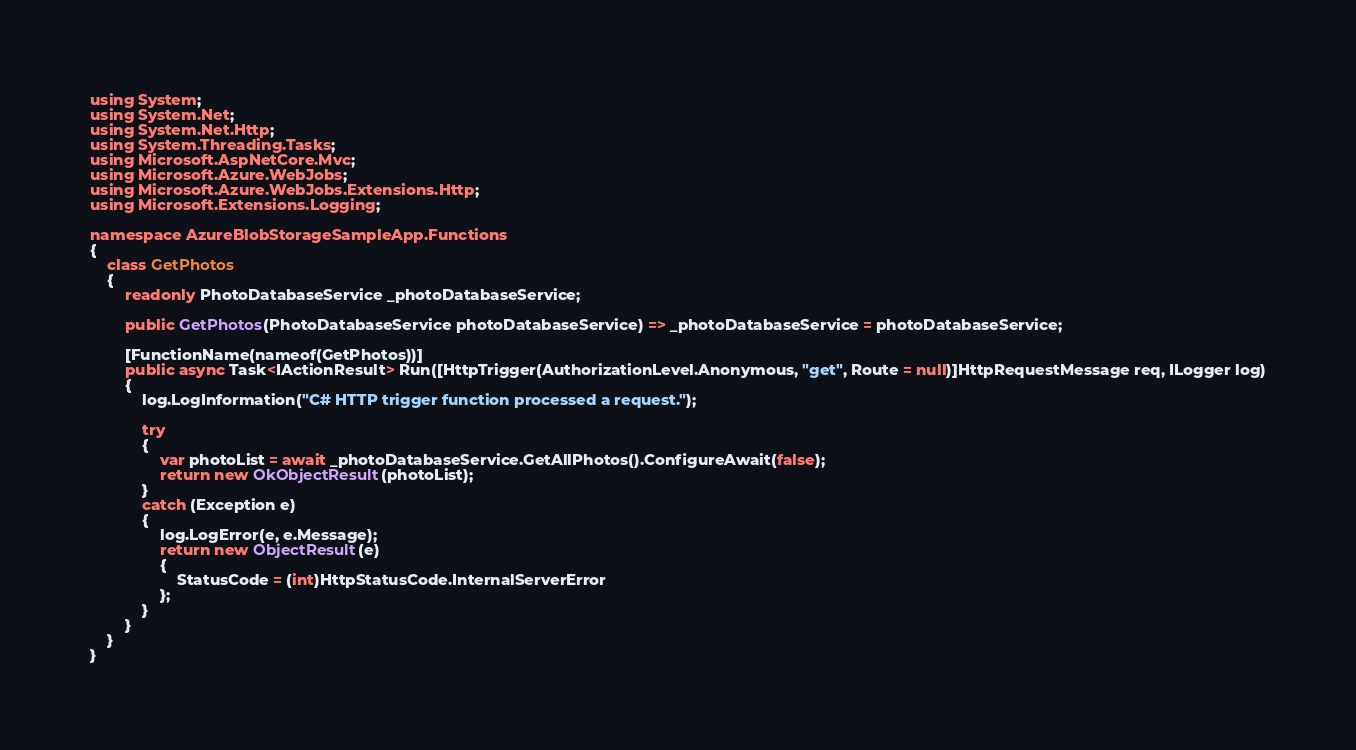<code> <loc_0><loc_0><loc_500><loc_500><_C#_>using System;
using System.Net;
using System.Net.Http;
using System.Threading.Tasks;
using Microsoft.AspNetCore.Mvc;
using Microsoft.Azure.WebJobs;
using Microsoft.Azure.WebJobs.Extensions.Http;
using Microsoft.Extensions.Logging;

namespace AzureBlobStorageSampleApp.Functions
{
    class GetPhotos
    {
        readonly PhotoDatabaseService _photoDatabaseService;

        public GetPhotos(PhotoDatabaseService photoDatabaseService) => _photoDatabaseService = photoDatabaseService;

        [FunctionName(nameof(GetPhotos))]
        public async Task<IActionResult> Run([HttpTrigger(AuthorizationLevel.Anonymous, "get", Route = null)]HttpRequestMessage req, ILogger log)
        {
            log.LogInformation("C# HTTP trigger function processed a request.");

            try
            {
                var photoList = await _photoDatabaseService.GetAllPhotos().ConfigureAwait(false);
                return new OkObjectResult(photoList);
            }
            catch (Exception e)
            {
                log.LogError(e, e.Message);
                return new ObjectResult(e)
                {
                    StatusCode = (int)HttpStatusCode.InternalServerError
                };
            }
        }
    }
}
</code> 